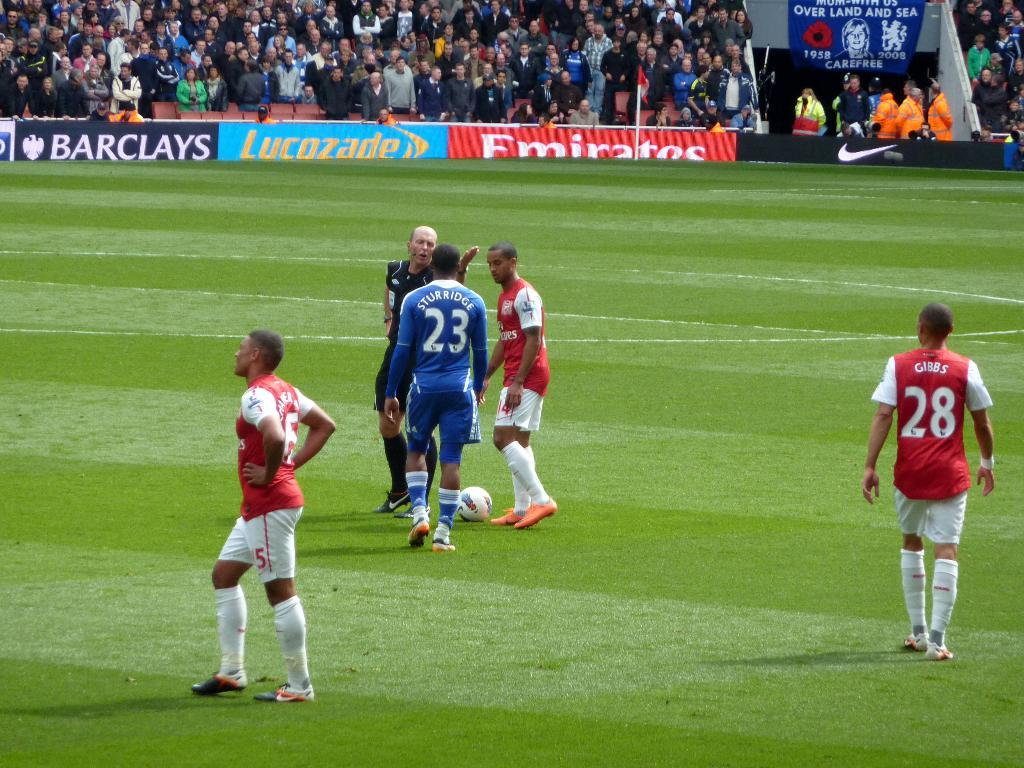<image>
Give a short and clear explanation of the subsequent image. Sturridge, number 23, talks with the referee in a soccer match. 